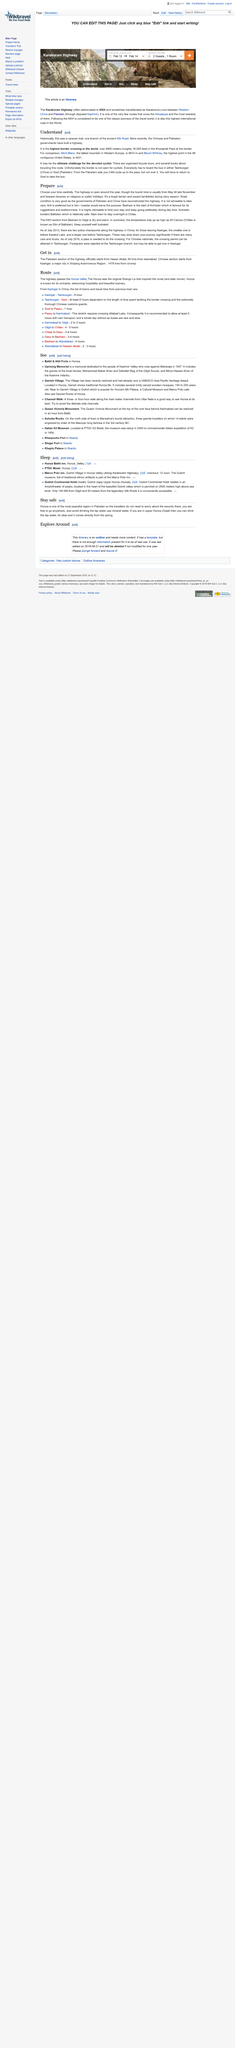Highlight a few significant elements in this photo. Mont Blanc is the tallest mountain in Western Europe, making it a prominent landmark for those who journey across the Alps. The Silk Road is the highest border crossing in the world, at which travelers must navigate steep elevation changes to cross from one country to another. Mount Whitney, with a height of 4421 meters, is a prominent landmark in the United States. 